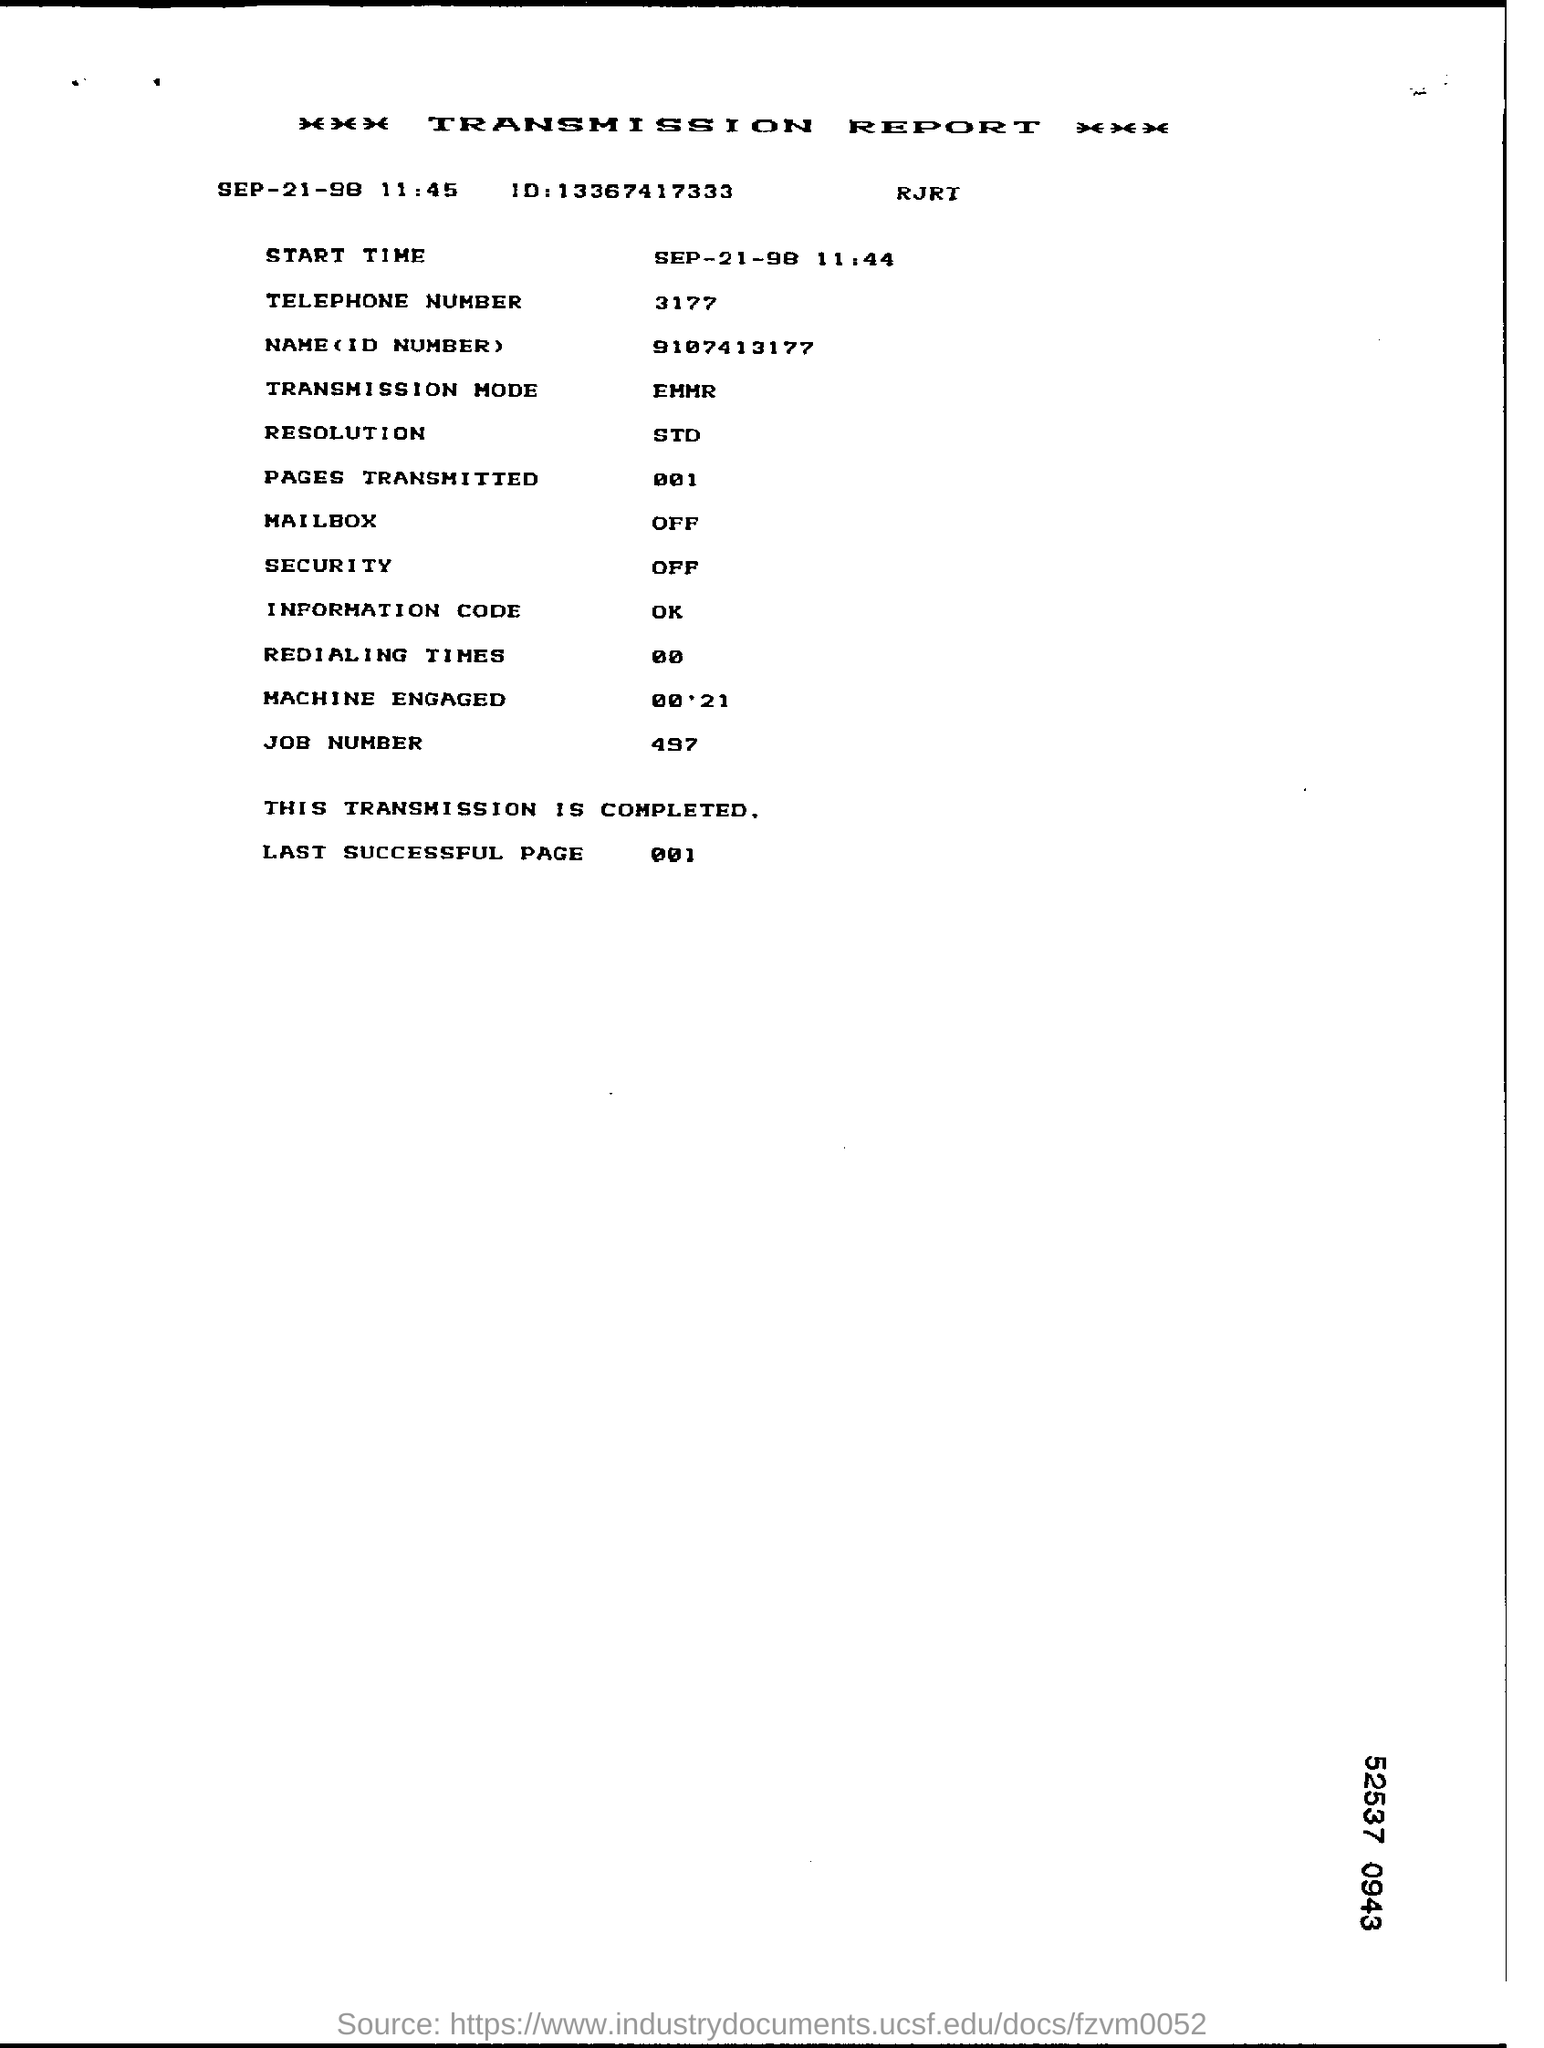Can you explain why page 001 is specified as the last successful page in this report? In the transmission report, page 001 is listed as the last successful page to confirm that this was the final part of the document that was successfully transmitted without any errors. It signals the end of the transmission process. 